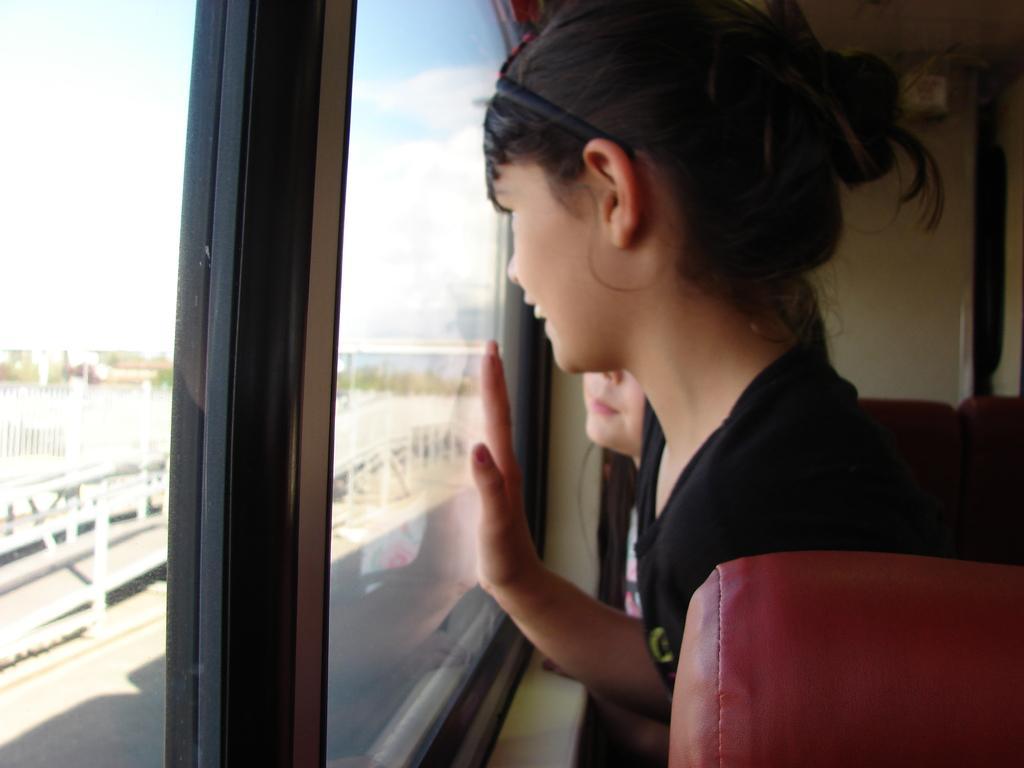Please provide a concise description of this image. In this image on the right side, I can see two people standing near the window. On the left side I can see the clouds in the sky. 